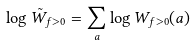Convert formula to latex. <formula><loc_0><loc_0><loc_500><loc_500>\log \tilde { W } _ { f > 0 } = \sum _ { a } \log W _ { f > 0 } ( a )</formula> 